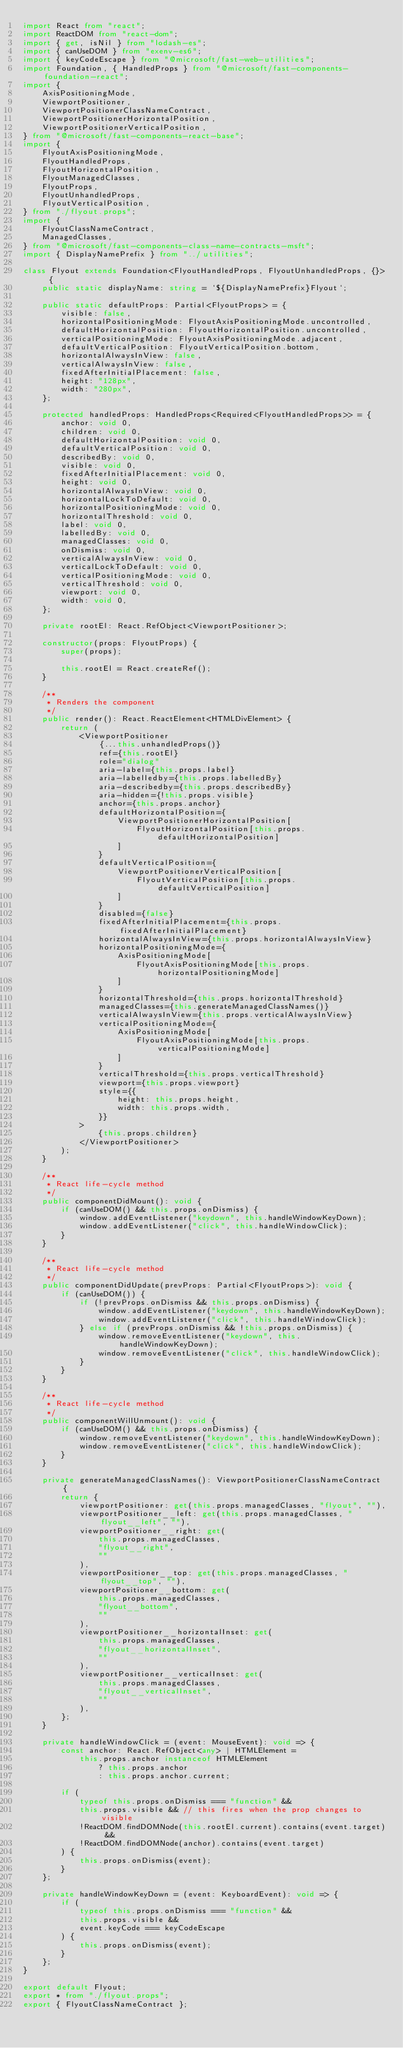<code> <loc_0><loc_0><loc_500><loc_500><_TypeScript_>import React from "react";
import ReactDOM from "react-dom";
import { get, isNil } from "lodash-es";
import { canUseDOM } from "exenv-es6";
import { keyCodeEscape } from "@microsoft/fast-web-utilities";
import Foundation, { HandledProps } from "@microsoft/fast-components-foundation-react";
import {
    AxisPositioningMode,
    ViewportPositioner,
    ViewportPositionerClassNameContract,
    ViewportPositionerHorizontalPosition,
    ViewportPositionerVerticalPosition,
} from "@microsoft/fast-components-react-base";
import {
    FlyoutAxisPositioningMode,
    FlyoutHandledProps,
    FlyoutHorizontalPosition,
    FlyoutManagedClasses,
    FlyoutProps,
    FlyoutUnhandledProps,
    FlyoutVerticalPosition,
} from "./flyout.props";
import {
    FlyoutClassNameContract,
    ManagedClasses,
} from "@microsoft/fast-components-class-name-contracts-msft";
import { DisplayNamePrefix } from "../utilities";

class Flyout extends Foundation<FlyoutHandledProps, FlyoutUnhandledProps, {}> {
    public static displayName: string = `${DisplayNamePrefix}Flyout`;

    public static defaultProps: Partial<FlyoutProps> = {
        visible: false,
        horizontalPositioningMode: FlyoutAxisPositioningMode.uncontrolled,
        defaultHorizontalPosition: FlyoutHorizontalPosition.uncontrolled,
        verticalPositioningMode: FlyoutAxisPositioningMode.adjacent,
        defaultVerticalPosition: FlyoutVerticalPosition.bottom,
        horizontalAlwaysInView: false,
        verticalAlwaysInView: false,
        fixedAfterInitialPlacement: false,
        height: "128px",
        width: "280px",
    };

    protected handledProps: HandledProps<Required<FlyoutHandledProps>> = {
        anchor: void 0,
        children: void 0,
        defaultHorizontalPosition: void 0,
        defaultVerticalPosition: void 0,
        describedBy: void 0,
        visible: void 0,
        fixedAfterInitialPlacement: void 0,
        height: void 0,
        horizontalAlwaysInView: void 0,
        horizontalLockToDefault: void 0,
        horizontalPositioningMode: void 0,
        horizontalThreshold: void 0,
        label: void 0,
        labelledBy: void 0,
        managedClasses: void 0,
        onDismiss: void 0,
        verticalAlwaysInView: void 0,
        verticalLockToDefault: void 0,
        verticalPositioningMode: void 0,
        verticalThreshold: void 0,
        viewport: void 0,
        width: void 0,
    };

    private rootEl: React.RefObject<ViewportPositioner>;

    constructor(props: FlyoutProps) {
        super(props);

        this.rootEl = React.createRef();
    }

    /**
     * Renders the component
     */
    public render(): React.ReactElement<HTMLDivElement> {
        return (
            <ViewportPositioner
                {...this.unhandledProps()}
                ref={this.rootEl}
                role="dialog"
                aria-label={this.props.label}
                aria-labelledby={this.props.labelledBy}
                aria-describedby={this.props.describedBy}
                aria-hidden={!this.props.visible}
                anchor={this.props.anchor}
                defaultHorizontalPosition={
                    ViewportPositionerHorizontalPosition[
                        FlyoutHorizontalPosition[this.props.defaultHorizontalPosition]
                    ]
                }
                defaultVerticalPosition={
                    ViewportPositionerVerticalPosition[
                        FlyoutVerticalPosition[this.props.defaultVerticalPosition]
                    ]
                }
                disabled={false}
                fixedAfterInitialPlacement={this.props.fixedAfterInitialPlacement}
                horizontalAlwaysInView={this.props.horizontalAlwaysInView}
                horizontalPositioningMode={
                    AxisPositioningMode[
                        FlyoutAxisPositioningMode[this.props.horizontalPositioningMode]
                    ]
                }
                horizontalThreshold={this.props.horizontalThreshold}
                managedClasses={this.generateManagedClassNames()}
                verticalAlwaysInView={this.props.verticalAlwaysInView}
                verticalPositioningMode={
                    AxisPositioningMode[
                        FlyoutAxisPositioningMode[this.props.verticalPositioningMode]
                    ]
                }
                verticalThreshold={this.props.verticalThreshold}
                viewport={this.props.viewport}
                style={{
                    height: this.props.height,
                    width: this.props.width,
                }}
            >
                {this.props.children}
            </ViewportPositioner>
        );
    }

    /**
     * React life-cycle method
     */
    public componentDidMount(): void {
        if (canUseDOM() && this.props.onDismiss) {
            window.addEventListener("keydown", this.handleWindowKeyDown);
            window.addEventListener("click", this.handleWindowClick);
        }
    }

    /**
     * React life-cycle method
     */
    public componentDidUpdate(prevProps: Partial<FlyoutProps>): void {
        if (canUseDOM()) {
            if (!prevProps.onDismiss && this.props.onDismiss) {
                window.addEventListener("keydown", this.handleWindowKeyDown);
                window.addEventListener("click", this.handleWindowClick);
            } else if (prevProps.onDismiss && !this.props.onDismiss) {
                window.removeEventListener("keydown", this.handleWindowKeyDown);
                window.removeEventListener("click", this.handleWindowClick);
            }
        }
    }

    /**
     * React life-cycle method
     */
    public componentWillUnmount(): void {
        if (canUseDOM() && this.props.onDismiss) {
            window.removeEventListener("keydown", this.handleWindowKeyDown);
            window.removeEventListener("click", this.handleWindowClick);
        }
    }

    private generateManagedClassNames(): ViewportPositionerClassNameContract {
        return {
            viewportPositioner: get(this.props.managedClasses, "flyout", ""),
            viewportPositioner__left: get(this.props.managedClasses, "flyout__left", ""),
            viewportPositioner__right: get(
                this.props.managedClasses,
                "flyout__right",
                ""
            ),
            viewportPositioner__top: get(this.props.managedClasses, "flyout__top", ""),
            viewportPositioner__bottom: get(
                this.props.managedClasses,
                "flyout__bottom",
                ""
            ),
            viewportPositioner__horizontalInset: get(
                this.props.managedClasses,
                "flyout__horizontalInset",
                ""
            ),
            viewportPositioner__verticalInset: get(
                this.props.managedClasses,
                "flyout__verticalInset",
                ""
            ),
        };
    }

    private handleWindowClick = (event: MouseEvent): void => {
        const anchor: React.RefObject<any> | HTMLElement =
            this.props.anchor instanceof HTMLElement
                ? this.props.anchor
                : this.props.anchor.current;

        if (
            typeof this.props.onDismiss === "function" &&
            this.props.visible && // this fires when the prop changes to visible
            !ReactDOM.findDOMNode(this.rootEl.current).contains(event.target) &&
            !ReactDOM.findDOMNode(anchor).contains(event.target)
        ) {
            this.props.onDismiss(event);
        }
    };

    private handleWindowKeyDown = (event: KeyboardEvent): void => {
        if (
            typeof this.props.onDismiss === "function" &&
            this.props.visible &&
            event.keyCode === keyCodeEscape
        ) {
            this.props.onDismiss(event);
        }
    };
}

export default Flyout;
export * from "./flyout.props";
export { FlyoutClassNameContract };
</code> 